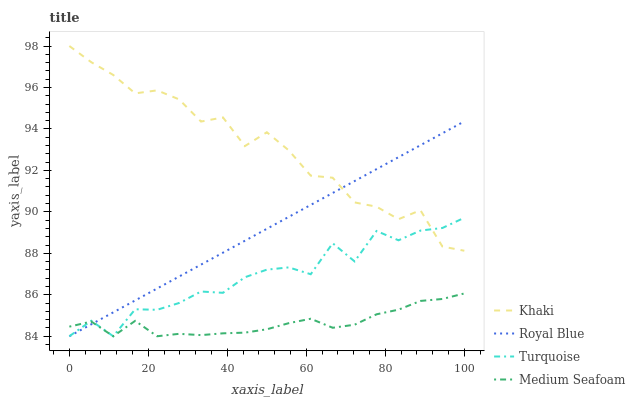Does Medium Seafoam have the minimum area under the curve?
Answer yes or no. Yes. Does Khaki have the maximum area under the curve?
Answer yes or no. Yes. Does Turquoise have the minimum area under the curve?
Answer yes or no. No. Does Turquoise have the maximum area under the curve?
Answer yes or no. No. Is Royal Blue the smoothest?
Answer yes or no. Yes. Is Turquoise the roughest?
Answer yes or no. Yes. Is Khaki the smoothest?
Answer yes or no. No. Is Khaki the roughest?
Answer yes or no. No. Does Royal Blue have the lowest value?
Answer yes or no. Yes. Does Khaki have the lowest value?
Answer yes or no. No. Does Khaki have the highest value?
Answer yes or no. Yes. Does Turquoise have the highest value?
Answer yes or no. No. Is Medium Seafoam less than Khaki?
Answer yes or no. Yes. Is Khaki greater than Medium Seafoam?
Answer yes or no. Yes. Does Turquoise intersect Medium Seafoam?
Answer yes or no. Yes. Is Turquoise less than Medium Seafoam?
Answer yes or no. No. Is Turquoise greater than Medium Seafoam?
Answer yes or no. No. Does Medium Seafoam intersect Khaki?
Answer yes or no. No. 